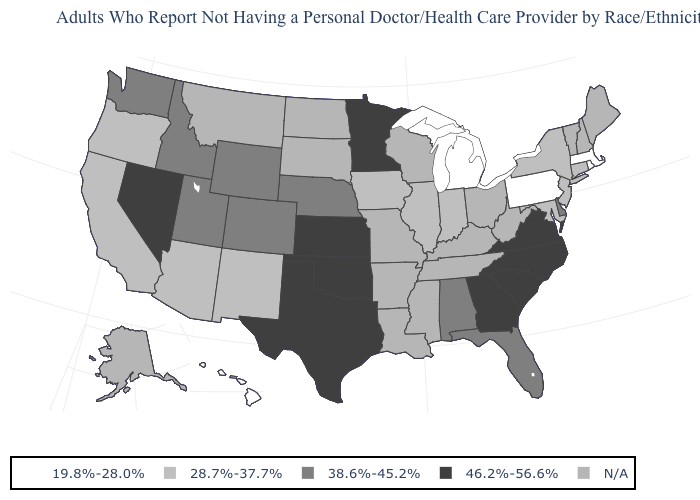Among the states that border Tennessee , which have the lowest value?
Be succinct. Alabama. What is the value of Vermont?
Give a very brief answer. N/A. What is the value of West Virginia?
Short answer required. N/A. Name the states that have a value in the range N/A?
Answer briefly. Alaska, Arkansas, Kentucky, Louisiana, Maine, Mississippi, Missouri, Montana, New Hampshire, North Dakota, Ohio, South Dakota, Tennessee, Vermont, West Virginia, Wisconsin. Does Kansas have the highest value in the USA?
Quick response, please. Yes. Among the states that border South Carolina , which have the highest value?
Be succinct. Georgia, North Carolina. Which states have the highest value in the USA?
Give a very brief answer. Georgia, Kansas, Minnesota, Nevada, North Carolina, Oklahoma, South Carolina, Texas, Virginia. What is the lowest value in states that border New York?
Quick response, please. 19.8%-28.0%. What is the value of Ohio?
Short answer required. N/A. What is the value of Louisiana?
Quick response, please. N/A. Name the states that have a value in the range 28.7%-37.7%?
Give a very brief answer. Arizona, California, Connecticut, Illinois, Indiana, Iowa, Maryland, New Jersey, New Mexico, New York, Oregon. Name the states that have a value in the range 38.6%-45.2%?
Short answer required. Alabama, Colorado, Delaware, Florida, Idaho, Nebraska, Utah, Washington, Wyoming. What is the value of West Virginia?
Short answer required. N/A. What is the highest value in states that border Rhode Island?
Short answer required. 28.7%-37.7%. 